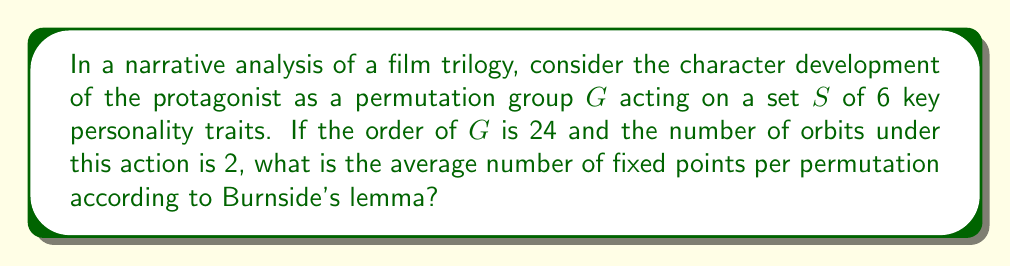Show me your answer to this math problem. Let's approach this step-by-step using Burnside's lemma and the given information:

1) Burnside's lemma states that the number of orbits $|S/G|$ is equal to the average number of fixed points over all permutations in $G$:

   $$|S/G| = \frac{1}{|G|} \sum_{g \in G} |S^g|$$

   Where $|S^g|$ is the number of elements in $S$ fixed by $g$.

2) We are given:
   - $|S| = 6$ (6 key personality traits)
   - $|G| = 24$ (order of the permutation group)
   - $|S/G| = 2$ (number of orbits)

3) Let's call the average number of fixed points $x$. Then according to Burnside's lemma:

   $$2 = \frac{1}{24} \sum_{g \in G} |S^g| = \frac{1}{24} (24x) = x$$

4) Therefore, the average number of fixed points per permutation is 2.

This result suggests that, on average, each stage of the character's development (represented by a permutation in $G$) leaves 2 of the 6 key personality traits unchanged, while potentially altering the others. This could represent a balance between character growth and maintaining core traits throughout the narrative.
Answer: 2 